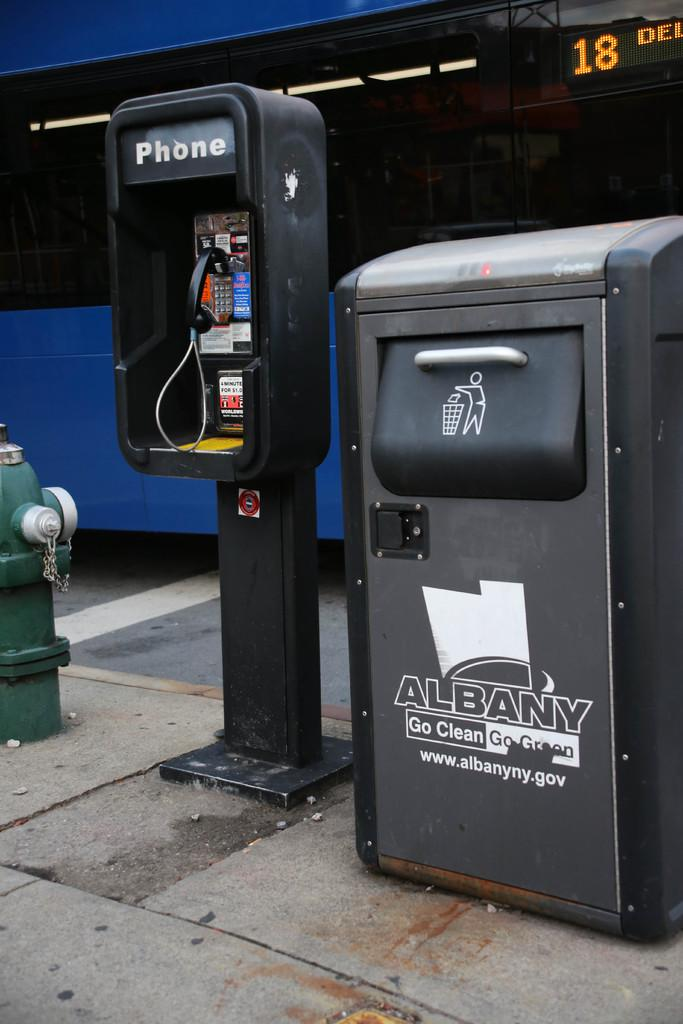<image>
Write a terse but informative summary of the picture. A city garbage can in Albany is to the right of a pay phone. 